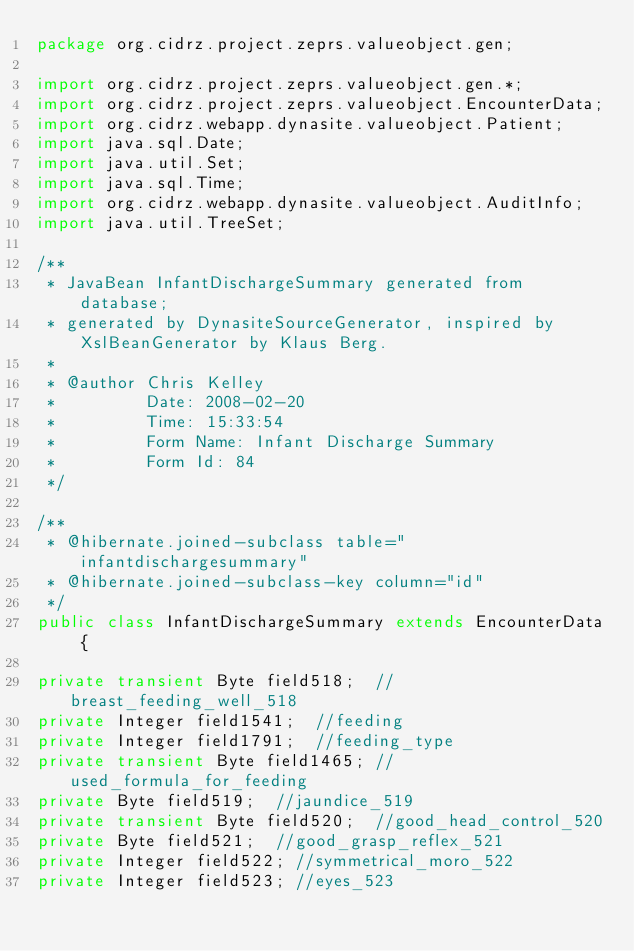<code> <loc_0><loc_0><loc_500><loc_500><_Java_>package org.cidrz.project.zeprs.valueobject.gen;

import org.cidrz.project.zeprs.valueobject.gen.*;
import org.cidrz.project.zeprs.valueobject.EncounterData;
import org.cidrz.webapp.dynasite.valueobject.Patient;
import java.sql.Date;
import java.util.Set;
import java.sql.Time;
import org.cidrz.webapp.dynasite.valueobject.AuditInfo;
import java.util.TreeSet;

/**
 * JavaBean InfantDischargeSummary generated from database;
 * generated by DynasiteSourceGenerator, inspired by XslBeanGenerator by Klaus Berg.
 *
 * @author Chris Kelley
 *         Date: 2008-02-20
 *         Time: 15:33:54
 *         Form Name: Infant Discharge Summary
 *         Form Id: 84
 */

/**
 * @hibernate.joined-subclass table="infantdischargesummary"
 * @hibernate.joined-subclass-key column="id"
 */
public class InfantDischargeSummary extends EncounterData {

private transient Byte field518;	//breast_feeding_well_518
private Integer field1541;	//feeding
private Integer field1791;	//feeding_type
private transient Byte field1465;	//used_formula_for_feeding
private Byte field519;	//jaundice_519
private transient Byte field520;	//good_head_control_520
private Byte field521;	//good_grasp_reflex_521
private Integer field522;	//symmetrical_moro_522
private Integer field523;	//eyes_523</code> 